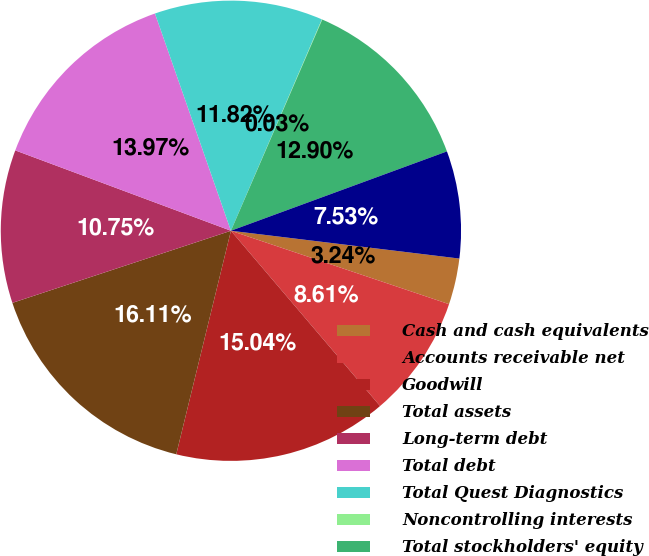Convert chart. <chart><loc_0><loc_0><loc_500><loc_500><pie_chart><fcel>Cash and cash equivalents<fcel>Accounts receivable net<fcel>Goodwill<fcel>Total assets<fcel>Long-term debt<fcel>Total debt<fcel>Total Quest Diagnostics<fcel>Noncontrolling interests<fcel>Total stockholders' equity<fcel>Net cash provided by operating<nl><fcel>3.24%<fcel>8.61%<fcel>15.04%<fcel>16.11%<fcel>10.75%<fcel>13.97%<fcel>11.82%<fcel>0.03%<fcel>12.9%<fcel>7.53%<nl></chart> 